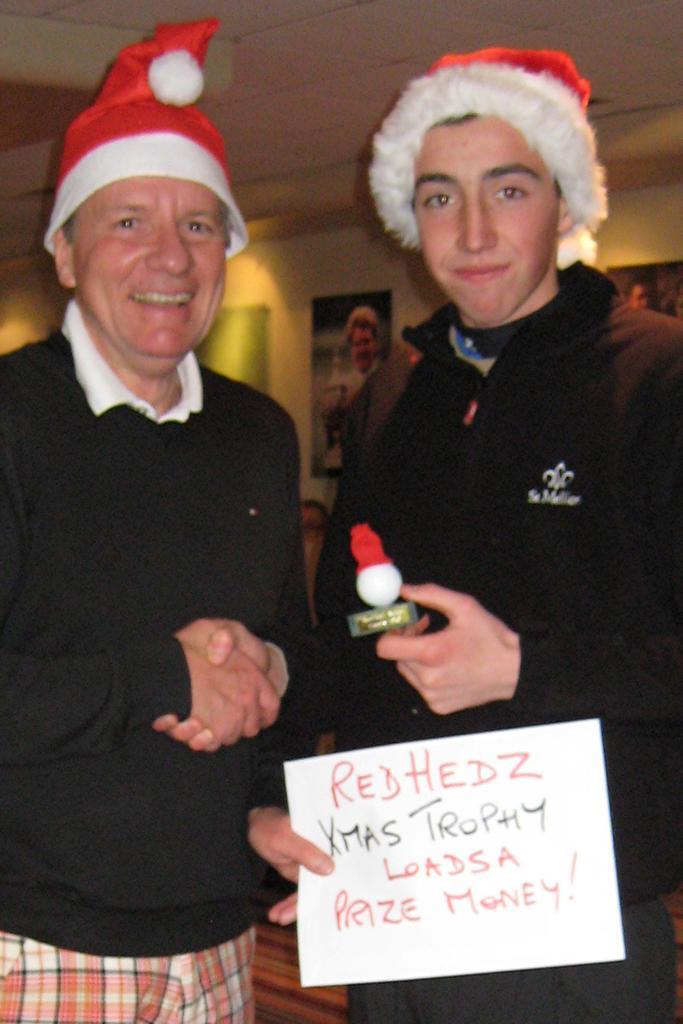In one or two sentences, can you explain what this image depicts? In the image there are two persons in black dress and christmas cap shaking hands and smiling, behind them there are pictures on the wall. 